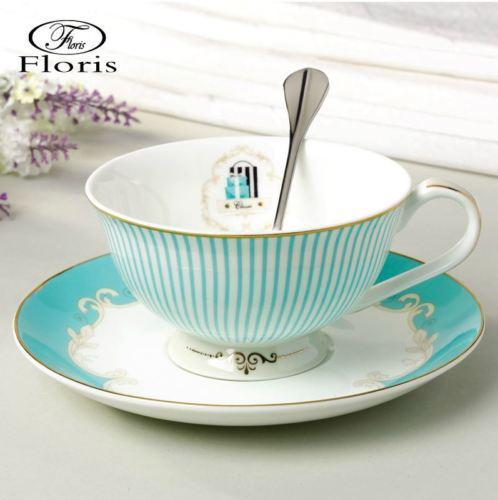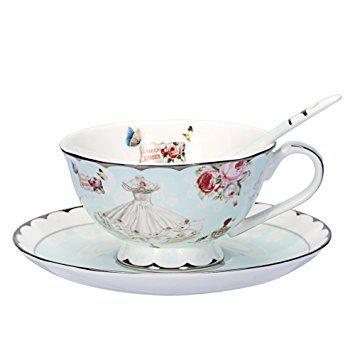The first image is the image on the left, the second image is the image on the right. Given the left and right images, does the statement "One of the cups has flowers printed on it." hold true? Answer yes or no. Yes. 